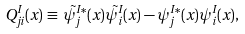<formula> <loc_0><loc_0><loc_500><loc_500>Q _ { j i } ^ { I } ( { x } ) \, \equiv \, \tilde { \psi } _ { j } ^ { I * } ( { x } ) \tilde { \psi } _ { i } ^ { I } ( { x } ) - \psi _ { j } ^ { I * } ( { x } ) \psi _ { i } ^ { I } ( { x } ) ,</formula> 